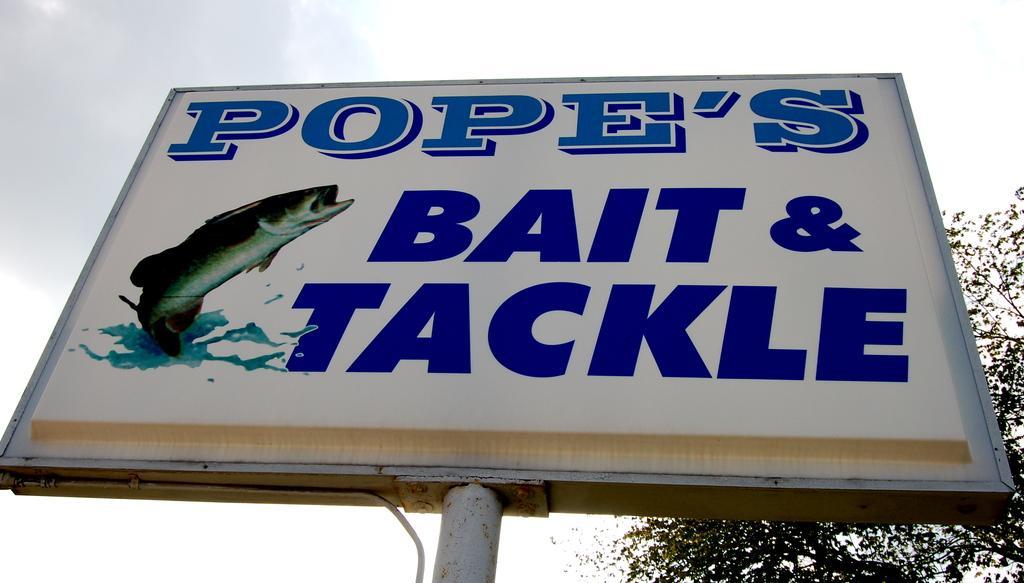In one or two sentences, can you explain what this image depicts? In the image we can see a hoarding. Behind the hoarding there are some trees and clouds and sky. 